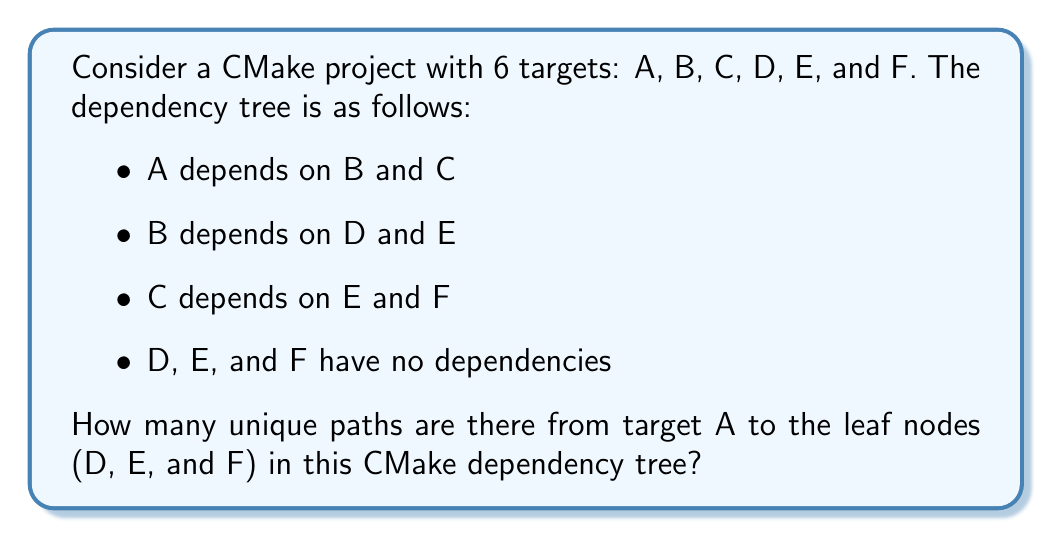Can you answer this question? Let's approach this step-by-step:

1) First, let's visualize the dependency tree:

   [asy]
   import graph;
   
   size(200);
   
   void drawNode(pair p, string s) {
     fill(circle(p, 0.3), white);
     draw(circle(p, 0.3));
     label(s, p);
   }
   
   pair A = (0,2);
   pair B = (-1,1);
   pair C = (1,1);
   pair D = (-1.5,0);
   pair E = (0,0);
   pair F = (1.5,0);
   
   drawNode(A, "A");
   drawNode(B, "B");
   drawNode(C, "C");
   drawNode(D, "D");
   drawNode(E, "E");
   drawNode(F, "F");
   
   draw(A--B);
   draw(A--C);
   draw(B--D);
   draw(B--E);
   draw(C--E);
   draw(C--F);
   [/asy]

2) To count the unique paths, we need to consider all possible ways to reach D, E, and F from A.

3) Paths to D:
   There's only one path: A → B → D
   Count: 1

4) Paths to E:
   There are two paths:
   - A → B → E
   - A → C → E
   Count: 2

5) Paths to F:
   There's only one path: A → C → F
   Count: 1

6) To get the total number of unique paths, we sum up all these paths:
   $$ \text{Total paths} = \text{Paths to D} + \text{Paths to E} + \text{Paths to F} $$
   $$ \text{Total paths} = 1 + 2 + 1 = 4 $$

Therefore, there are 4 unique paths from target A to the leaf nodes in this CMake dependency tree.
Answer: 4 